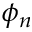Convert formula to latex. <formula><loc_0><loc_0><loc_500><loc_500>\phi _ { n }</formula> 